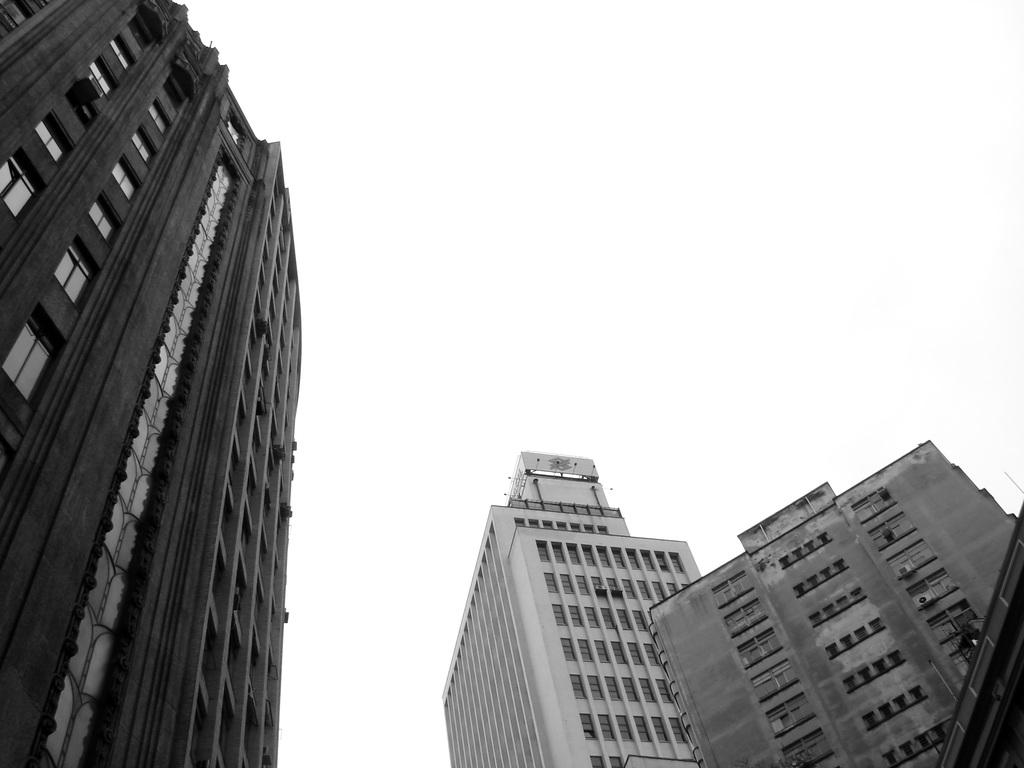What type of structures are located in the front of the image? There are buildings in the front of the image. What is the color of the background in the image? The background of the image is white. Are there any cemeteries visible in the image? There is no mention of a cemetery in the provided facts, and therefore it cannot be determined if one is present in the image. What type of holiday is being celebrated in the image? There is no indication of a holiday being celebrated in the image, as the provided facts only mention buildings and a white background. 